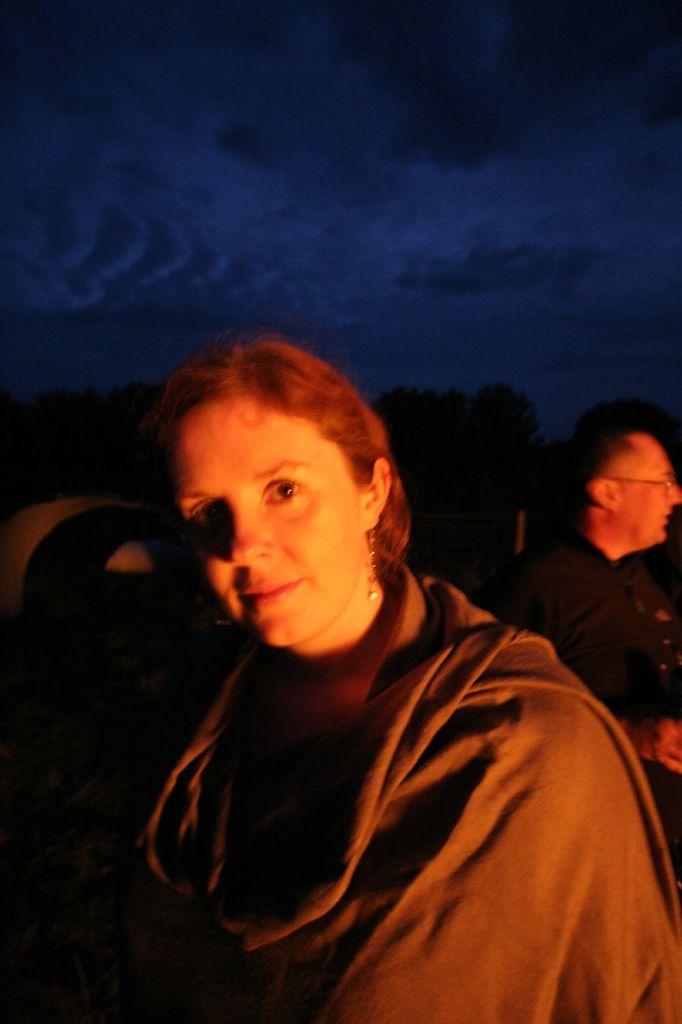How would you summarize this image in a sentence or two? In this picture we can see one woman wearing shawl, back side, we can see one person. 